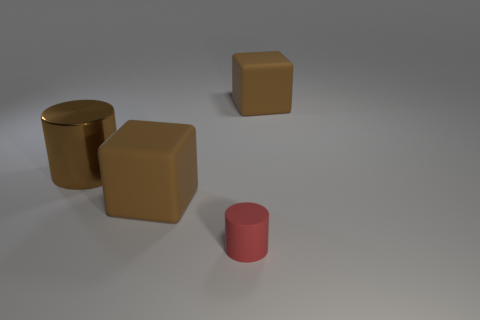Add 1 big matte objects. How many objects exist? 5 Subtract all red cylinders. How many cylinders are left? 1 Subtract all purple cylinders. Subtract all purple balls. How many cylinders are left? 2 Subtract all yellow spheres. How many brown cylinders are left? 1 Subtract all shiny objects. Subtract all big brown matte objects. How many objects are left? 1 Add 3 brown cylinders. How many brown cylinders are left? 4 Add 3 small red matte cylinders. How many small red matte cylinders exist? 4 Subtract 0 red blocks. How many objects are left? 4 Subtract 2 blocks. How many blocks are left? 0 